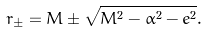<formula> <loc_0><loc_0><loc_500><loc_500>r _ { \pm } = M \pm \sqrt { M ^ { 2 } - \alpha ^ { 2 } - e ^ { 2 } } .</formula> 